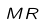Convert formula to latex. <formula><loc_0><loc_0><loc_500><loc_500>M R</formula> 